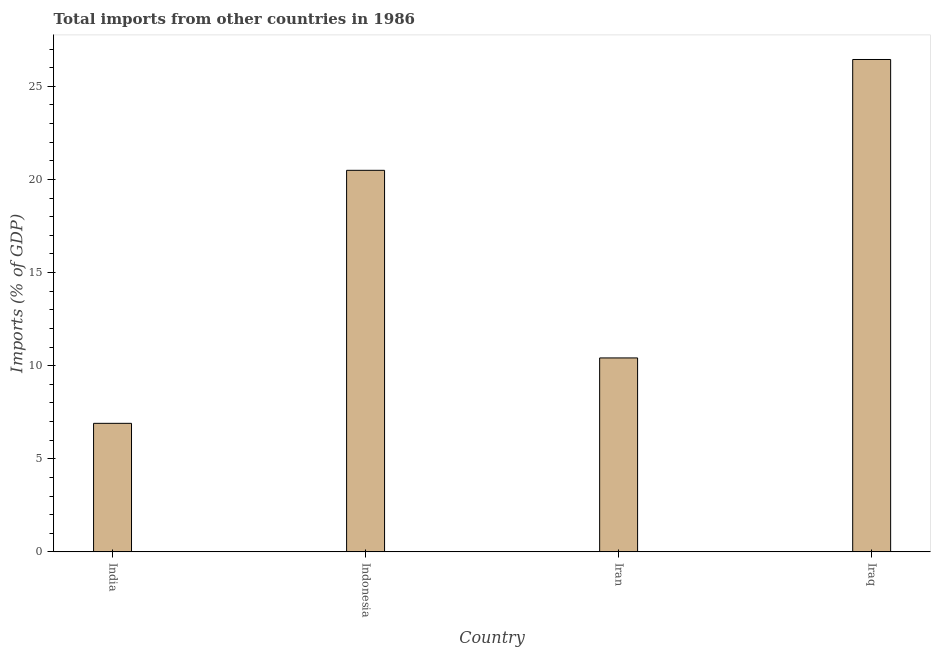Does the graph contain grids?
Ensure brevity in your answer.  No. What is the title of the graph?
Your answer should be compact. Total imports from other countries in 1986. What is the label or title of the X-axis?
Offer a terse response. Country. What is the label or title of the Y-axis?
Make the answer very short. Imports (% of GDP). What is the total imports in Iraq?
Offer a very short reply. 26.44. Across all countries, what is the maximum total imports?
Provide a short and direct response. 26.44. Across all countries, what is the minimum total imports?
Your answer should be very brief. 6.9. In which country was the total imports maximum?
Your response must be concise. Iraq. In which country was the total imports minimum?
Ensure brevity in your answer.  India. What is the sum of the total imports?
Your answer should be very brief. 64.24. What is the difference between the total imports in Iran and Iraq?
Keep it short and to the point. -16.02. What is the average total imports per country?
Ensure brevity in your answer.  16.06. What is the median total imports?
Ensure brevity in your answer.  15.45. What is the ratio of the total imports in India to that in Indonesia?
Your response must be concise. 0.34. Is the total imports in India less than that in Indonesia?
Make the answer very short. Yes. Is the difference between the total imports in Indonesia and Iran greater than the difference between any two countries?
Your answer should be very brief. No. What is the difference between the highest and the second highest total imports?
Offer a terse response. 5.95. Is the sum of the total imports in Indonesia and Iraq greater than the maximum total imports across all countries?
Offer a very short reply. Yes. What is the difference between the highest and the lowest total imports?
Your answer should be very brief. 19.54. In how many countries, is the total imports greater than the average total imports taken over all countries?
Keep it short and to the point. 2. Are all the bars in the graph horizontal?
Provide a short and direct response. No. What is the difference between two consecutive major ticks on the Y-axis?
Ensure brevity in your answer.  5. Are the values on the major ticks of Y-axis written in scientific E-notation?
Keep it short and to the point. No. What is the Imports (% of GDP) in India?
Provide a short and direct response. 6.9. What is the Imports (% of GDP) in Indonesia?
Make the answer very short. 20.49. What is the Imports (% of GDP) in Iran?
Offer a very short reply. 10.41. What is the Imports (% of GDP) of Iraq?
Your answer should be very brief. 26.44. What is the difference between the Imports (% of GDP) in India and Indonesia?
Keep it short and to the point. -13.58. What is the difference between the Imports (% of GDP) in India and Iran?
Your response must be concise. -3.51. What is the difference between the Imports (% of GDP) in India and Iraq?
Make the answer very short. -19.54. What is the difference between the Imports (% of GDP) in Indonesia and Iran?
Your answer should be very brief. 10.07. What is the difference between the Imports (% of GDP) in Indonesia and Iraq?
Your answer should be compact. -5.95. What is the difference between the Imports (% of GDP) in Iran and Iraq?
Offer a very short reply. -16.02. What is the ratio of the Imports (% of GDP) in India to that in Indonesia?
Keep it short and to the point. 0.34. What is the ratio of the Imports (% of GDP) in India to that in Iran?
Give a very brief answer. 0.66. What is the ratio of the Imports (% of GDP) in India to that in Iraq?
Keep it short and to the point. 0.26. What is the ratio of the Imports (% of GDP) in Indonesia to that in Iran?
Ensure brevity in your answer.  1.97. What is the ratio of the Imports (% of GDP) in Indonesia to that in Iraq?
Ensure brevity in your answer.  0.78. What is the ratio of the Imports (% of GDP) in Iran to that in Iraq?
Your response must be concise. 0.39. 